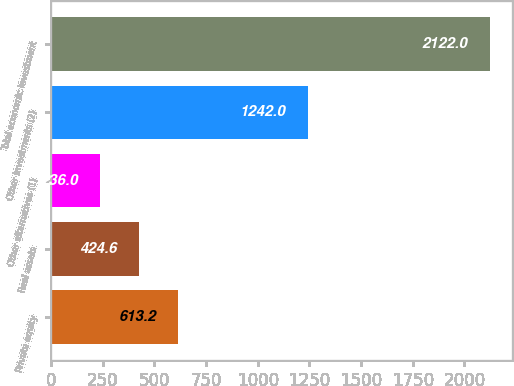Convert chart to OTSL. <chart><loc_0><loc_0><loc_500><loc_500><bar_chart><fcel>Private equity<fcel>Real assets<fcel>Other alternatives (1)<fcel>Other investments (2)<fcel>Total economic investment<nl><fcel>613.2<fcel>424.6<fcel>236<fcel>1242<fcel>2122<nl></chart> 